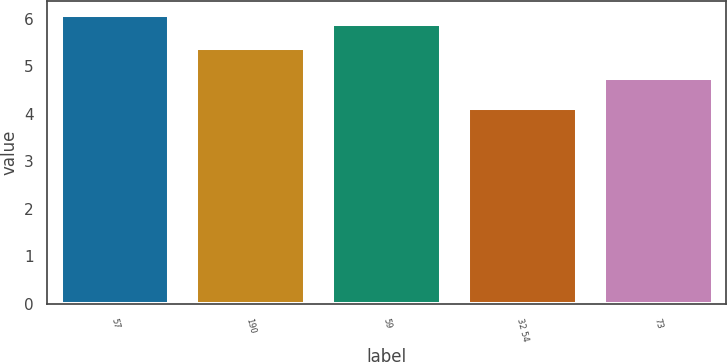Convert chart to OTSL. <chart><loc_0><loc_0><loc_500><loc_500><bar_chart><fcel>57<fcel>190<fcel>59<fcel>32 54<fcel>73<nl><fcel>6.07<fcel>5.38<fcel>5.88<fcel>4.12<fcel>4.75<nl></chart> 